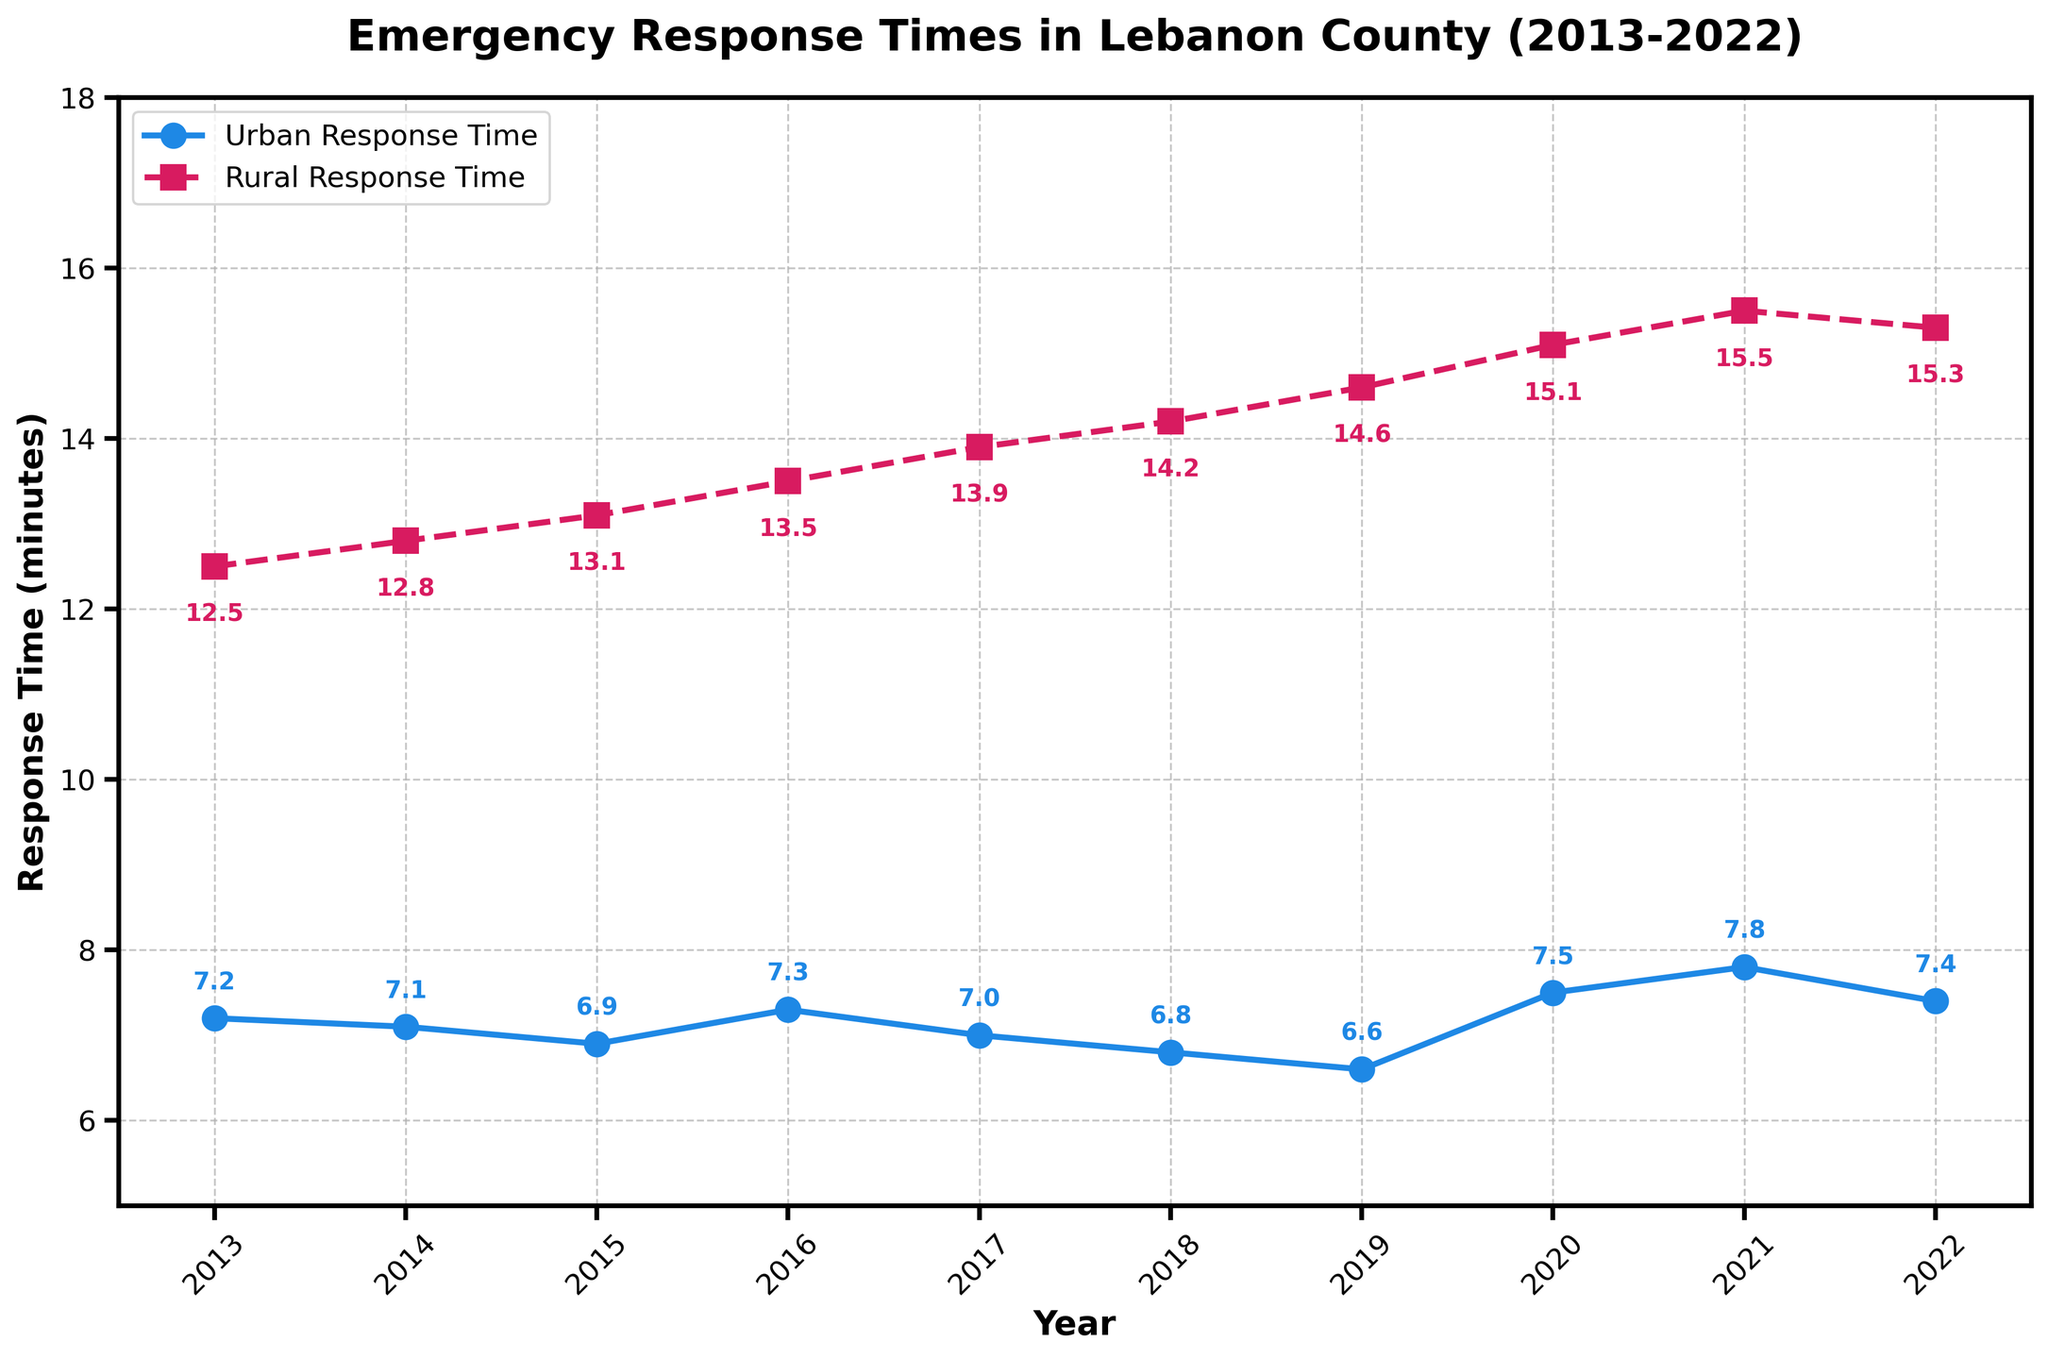How has the urban response time trend compared to the rural response time trend over the past 10 years? The line for urban response time fluctuates slightly but generally shows a slight decrease from 2013 to 2022. The rural response time trend consistently increases over the same period. This indicates that while urban response times have slightly improved or remained stable, rural response times have worsened.
Answer: Urban times slightly decreased, rural times increased Which year had the lowest urban response time and what was it? By looking at the line representing urban response time, the lowest point is around 2019. According to the annotations, the urban response time was 6.6 minutes.
Answer: 2019, 6.6 minutes Which year had the highest rural response time and what was it? By observing the highest point in the rural response time line, this occurs around 2021. The annotation indicates the rural response time was 15.5 minutes.
Answer: 2021, 15.5 minutes What is the difference between the urban and rural response times in 2018? According to the annotations, the urban response time in 2018 was 6.8 minutes and the rural response time was 14.2 minutes. The difference is calculated as 14.2 - 6.8.
Answer: 7.4 minutes How many years have the urban response times been below 7 minutes? By examining the points on the urban response time line and their annotations, the years with times below 7 minutes are 2015, 2018, and 2019. Counting these years gives 3.
Answer: 3 years In which years did both urban and rural response times increase compared to the previous year? Comparing the lines year by year, both urban and rural response times increased from 2019 to 2020, and again from 2020 to 2021.
Answer: 2019-2020, 2020-2021 What is the average urban response time over the 10-year period? Adding up all the urban response times and dividing by the number of years (7.2 + 7.1 + 6.9 + 7.3 + 7.0 + 6.8 + 6.6 + 7.5 + 7.8 + 7.4) / 10 results in the average.
Answer: 7.06 minutes Compare the steepness of change in rural response times between 2015 and 2019 with that from 2019 to 2021. Which period had a steeper change? The annual increase in rural response times between 2015 and 2019 was 1.5 (14.6 - 13.1) over 4 years, an average rate of increase of 0.375 per year. From 2019 to 2021, the increase was 0.9 (15.5 - 14.6) over 2 years, an average rate of 0.45 per year. The 2019-2021 period was steeper.
Answer: 2019-2021 period 